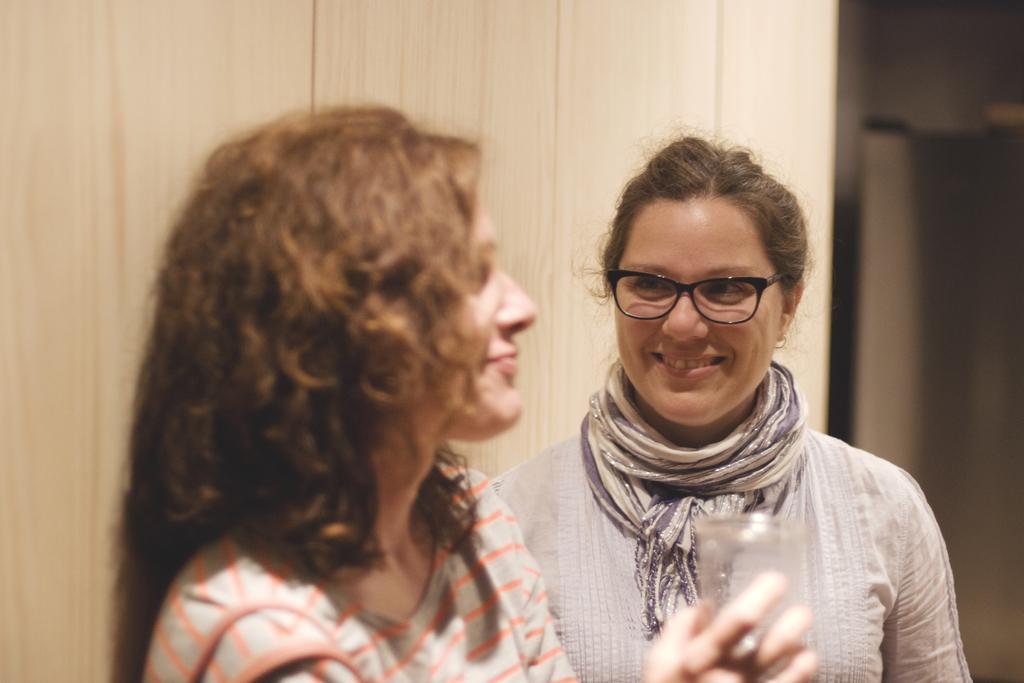Please provide a concise description of this image. In this image I can see two women wearing grey, orange and violet colored dresses. I can see one of the women is holding a glass in her hand and the other woman is wearing black colored spectacles. In the background I can see the cream colored surface. 